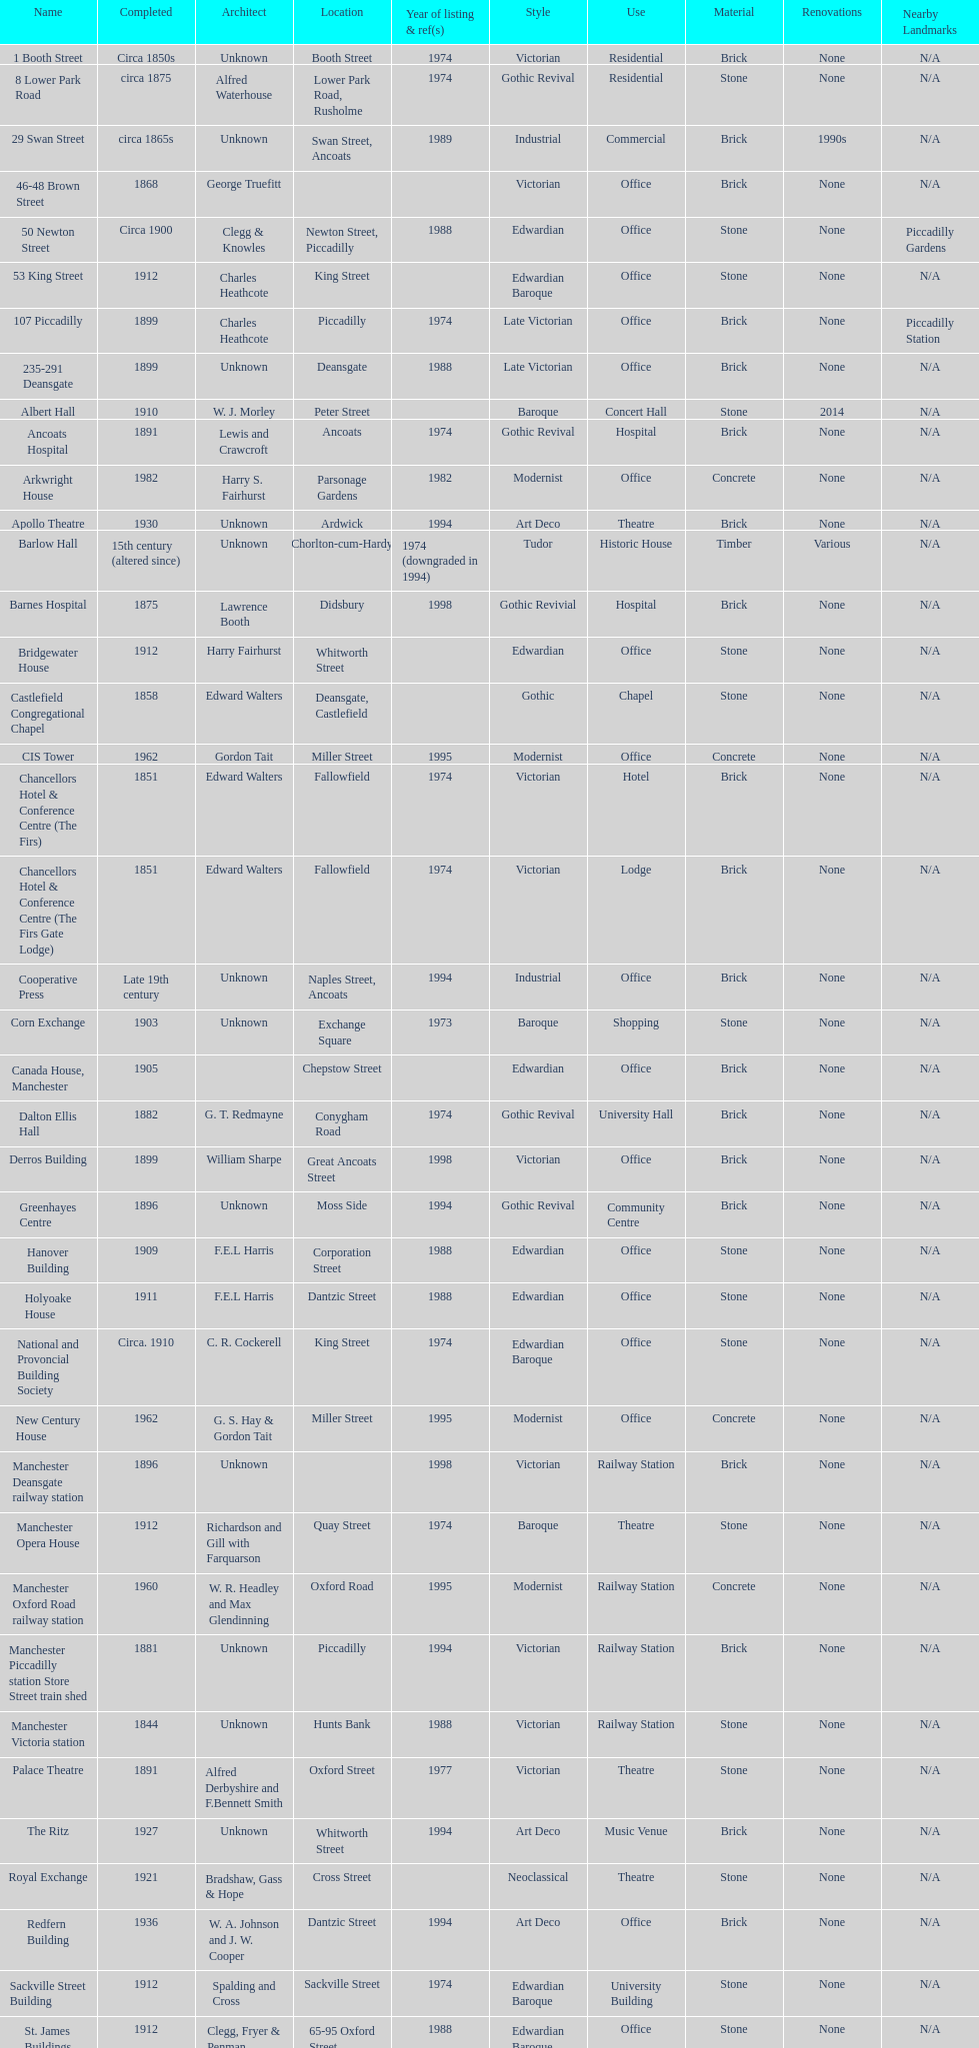Was charles heathcote the designer of ancoats hospital and apollo theatre? No. 